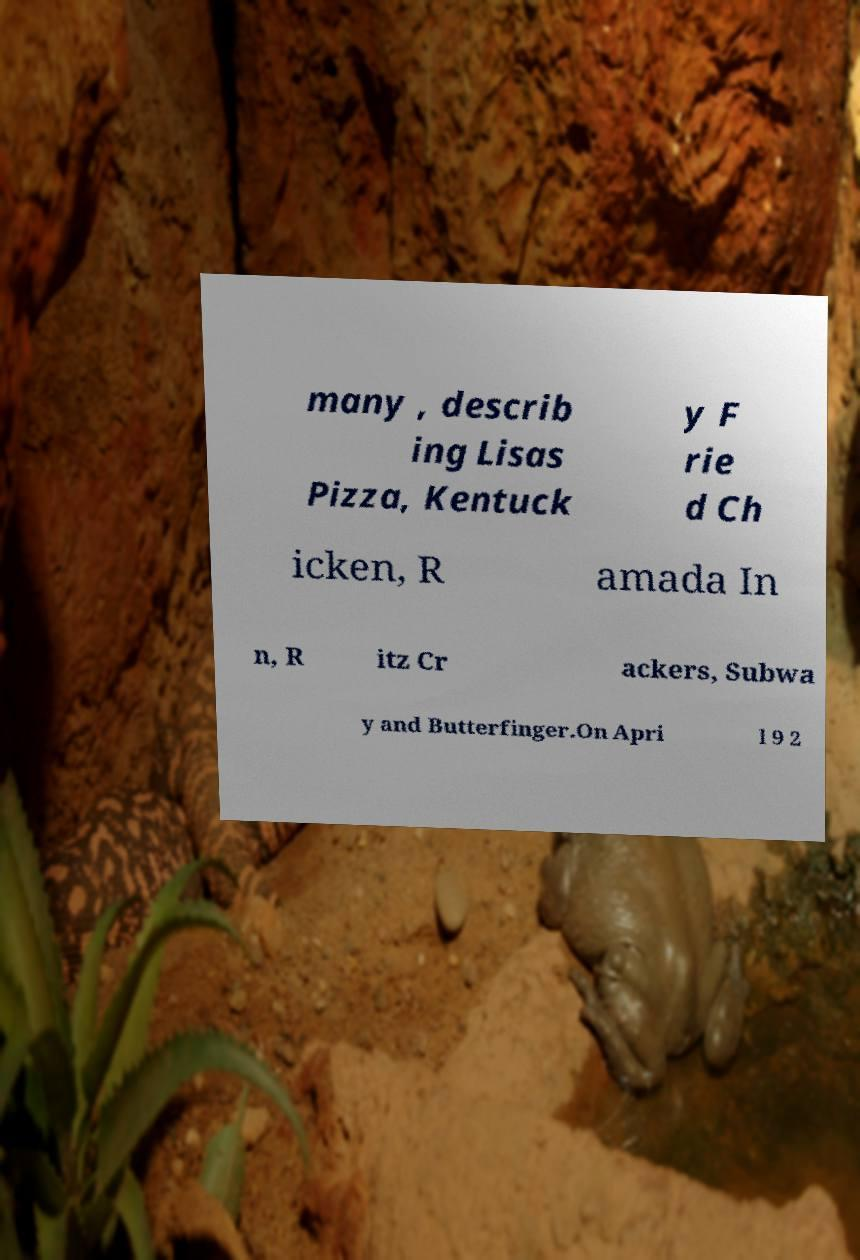For documentation purposes, I need the text within this image transcribed. Could you provide that? many , describ ing Lisas Pizza, Kentuck y F rie d Ch icken, R amada In n, R itz Cr ackers, Subwa y and Butterfinger.On Apri l 9 2 